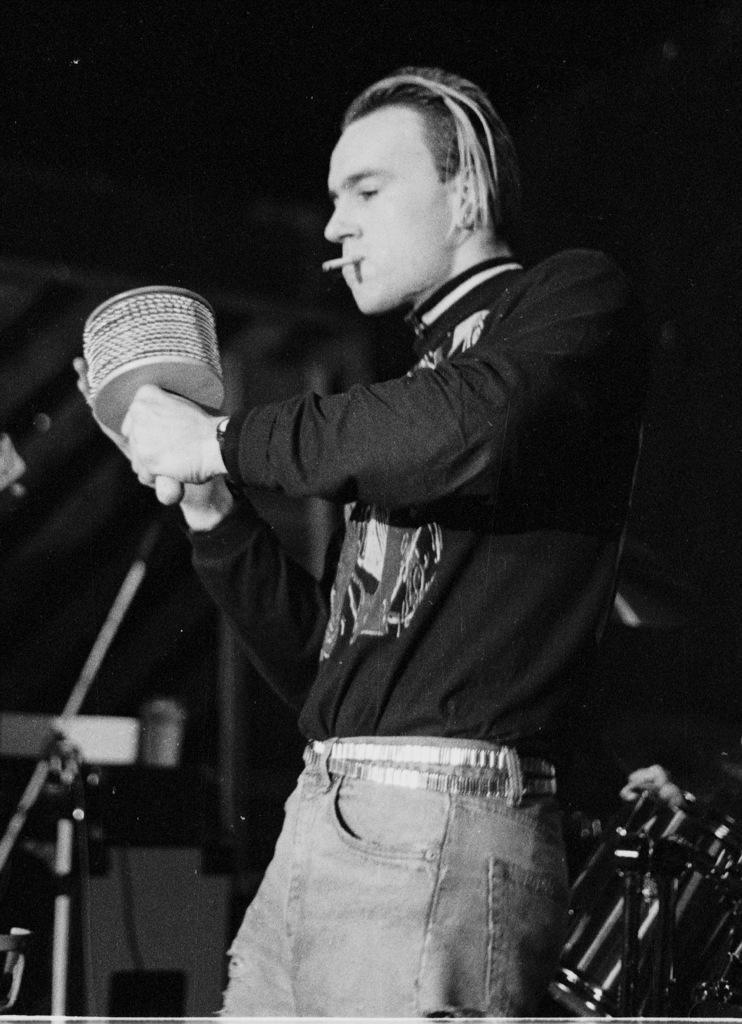Could you give a brief overview of what you see in this image? In this image there is a man standing and smoking also holding some thing in hand, behind him there are some instruments. 